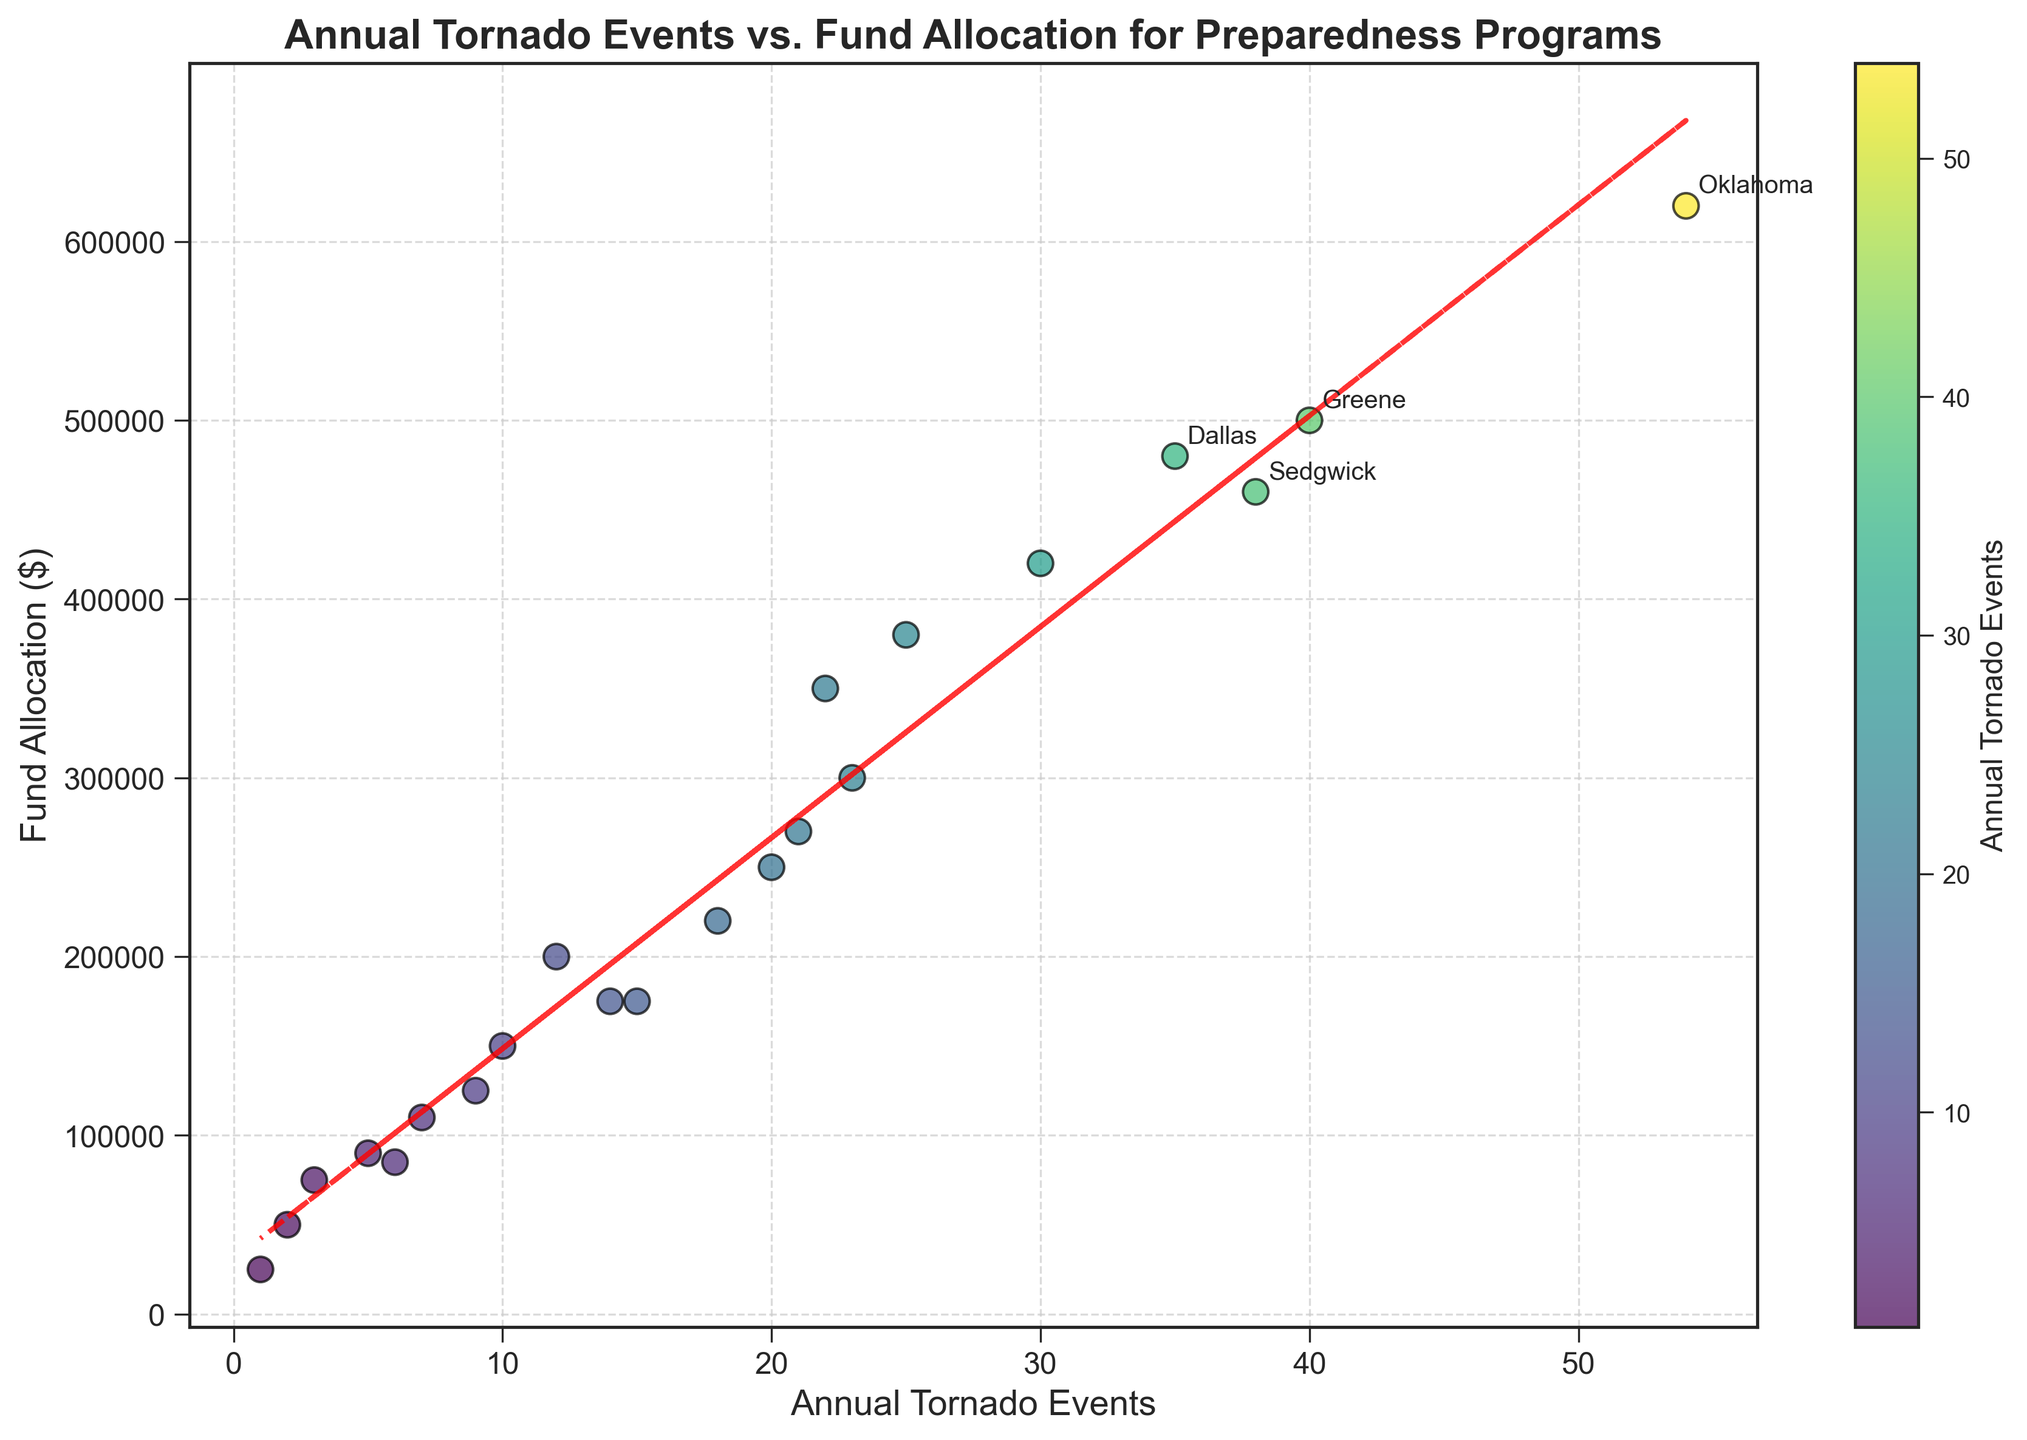What is the title of the scatter plot? The title of the scatter plot is given at the top of the figure.
Answer: Annual Tornado Events vs. Fund Allocation for Preparedness Programs How many counties are shown in the scatter plot? The total number of counties can be counted by the number of data points in the plot. Upon inspection, there are 22 data points representing different counties.
Answer: 22 What is the allocation for preparedness in the county with the highest annual tornado events? The county with the highest annual tornado events (Oklahoma with 54 events) has to be located on the scatter plot, and its corresponding y-axis value checked.
Answer: 620,000 dollars Which counties are highlighted for having either more than 30 tornado events or more than $500,000 in fund allocation? The figure annotates counties that meet these criteria. By observation, these counties are Dallas, Oklahoma, and Greene.
Answer: Dallas, Oklahoma, Greene Is there a general trend between annual tornado events and fund allocation, and what type of trend line is used? The scatter plot includes a red dashed trend line which shows the general relationship between the variables. By inspecting the trend line, one can deduce if it's upwards or downwards.
Answer: Upward trend line (suggesting a positive correlation) What is the fund allocation for a county with 18 annual tornado events? Locate the data point corresponding to 18 tornado events on the x-axis and check the corresponding y-axis value. The county is Douglas.
Answer: 220,000 dollars How many counties have fewer than 10 annual tornado events? Count the number of data points that fall below 10 on the x-axis of the scatter plot.
Answer: 4 counties Which county receives the least fund allocation and how many tornado events does it have? Identify the data point with the lowest position on the y-axis and check its corresponding x-axis value. The county is Webb with 1 tornado event.
Answer: Webb, 1 event Compare the fund allocation between Sedgwick and Jefferson. Which one is higher and by how much? Identify both data points on the scatter plot. Sedgwick has 38 events and 460,000 dollars, Jefferson has 20 events and 250,000 dollars. The difference in fund allocation can then be calculated.
Answer: Sedgwick is higher by 210,000 dollars (460,000 - 250,000) What observations can be made about fund allocation for counties with fewer than 5 annual tornado events? Identify the data points with fewer than 5 tornado events and summarize their fund allocations. The counties are Maricopa, Martin, and Webb, each receiving lower fund allocations, generally under 100,000 dollars.
Answer: Generally low fund allocations (<100,000 dollars) 